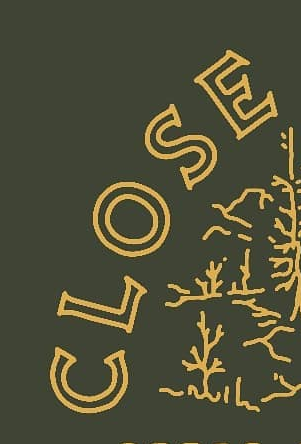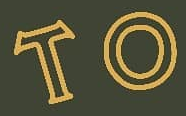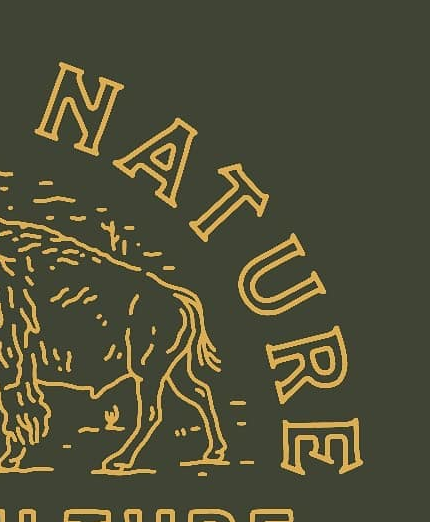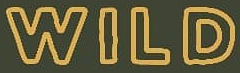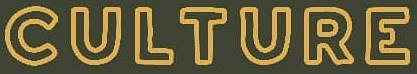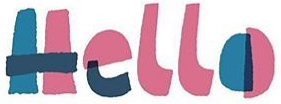Identify the words shown in these images in order, separated by a semicolon. CLOSE; TO; NATURE; WILD; CULTURE; Hello 